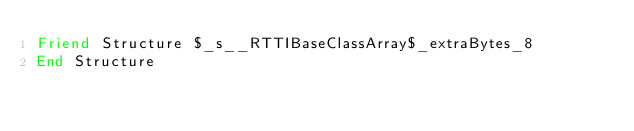Convert code to text. <code><loc_0><loc_0><loc_500><loc_500><_VisualBasic_>Friend Structure $_s__RTTIBaseClassArray$_extraBytes_8
End Structure
</code> 